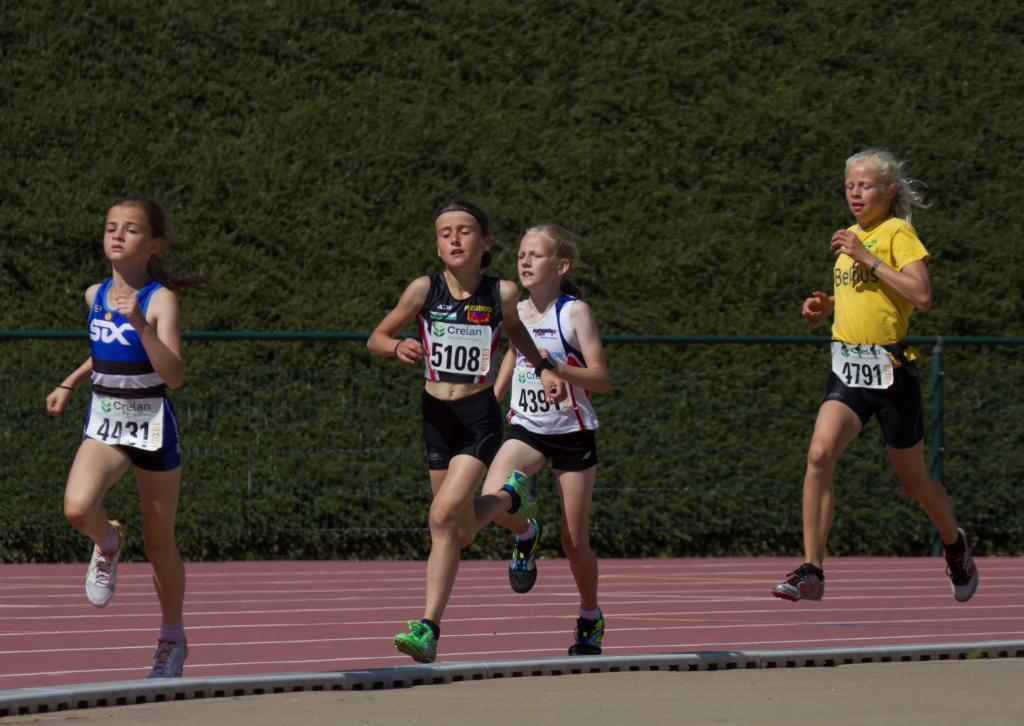Please provide a concise description of this image. In this image we can see a few people running, there is a pole and a metal rod, in the background we can see some trees. 